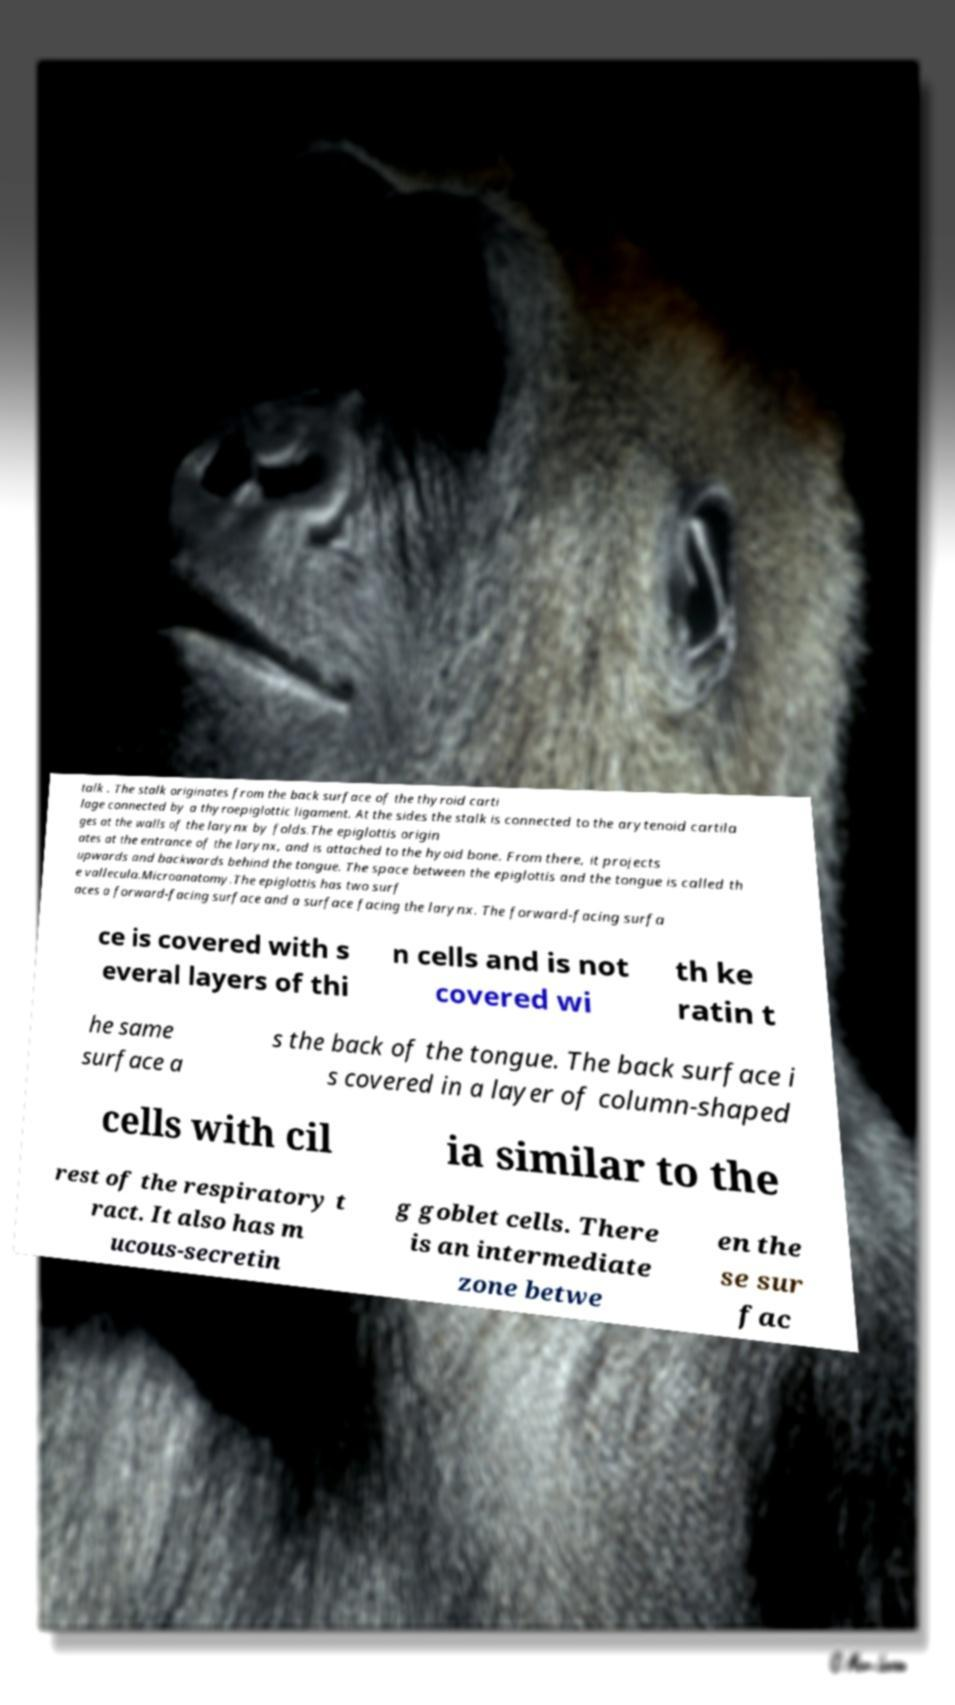Can you read and provide the text displayed in the image?This photo seems to have some interesting text. Can you extract and type it out for me? talk . The stalk originates from the back surface of the thyroid carti lage connected by a thyroepiglottic ligament. At the sides the stalk is connected to the arytenoid cartila ges at the walls of the larynx by folds.The epiglottis origin ates at the entrance of the larynx, and is attached to the hyoid bone. From there, it projects upwards and backwards behind the tongue. The space between the epiglottis and the tongue is called th e vallecula.Microanatomy.The epiglottis has two surf aces a forward-facing surface and a surface facing the larynx. The forward-facing surfa ce is covered with s everal layers of thi n cells and is not covered wi th ke ratin t he same surface a s the back of the tongue. The back surface i s covered in a layer of column-shaped cells with cil ia similar to the rest of the respiratory t ract. It also has m ucous-secretin g goblet cells. There is an intermediate zone betwe en the se sur fac 